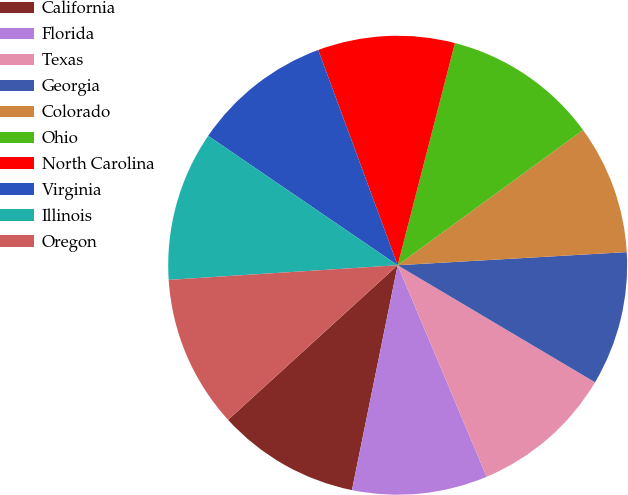Convert chart to OTSL. <chart><loc_0><loc_0><loc_500><loc_500><pie_chart><fcel>California<fcel>Florida<fcel>Texas<fcel>Georgia<fcel>Colorado<fcel>Ohio<fcel>North Carolina<fcel>Virginia<fcel>Illinois<fcel>Oregon<nl><fcel>10.04%<fcel>9.53%<fcel>10.14%<fcel>9.43%<fcel>9.12%<fcel>10.95%<fcel>9.64%<fcel>9.84%<fcel>10.55%<fcel>10.75%<nl></chart> 